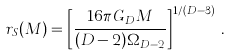<formula> <loc_0><loc_0><loc_500><loc_500>r _ { S } ( M ) = \left [ \frac { 1 6 \pi G _ { D } M } { ( D - 2 ) \Omega _ { D - 2 } } \right ] ^ { 1 / ( D - 3 ) } \, .</formula> 